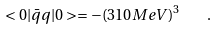Convert formula to latex. <formula><loc_0><loc_0><loc_500><loc_500>< 0 | \bar { q } q | 0 > = - ( 3 1 0 M e V ) ^ { 3 } \quad .</formula> 